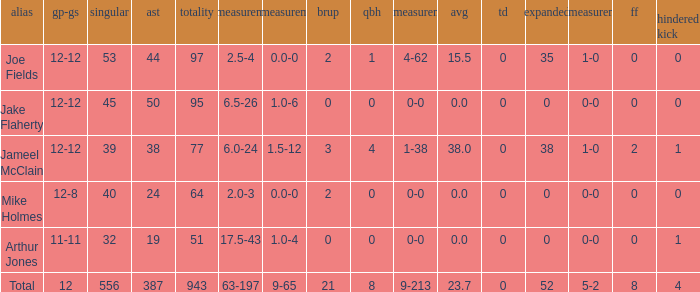How many tackle assists for the player who averages 23.7? 387.0. 